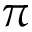Convert formula to latex. <formula><loc_0><loc_0><loc_500><loc_500>\pi</formula> 